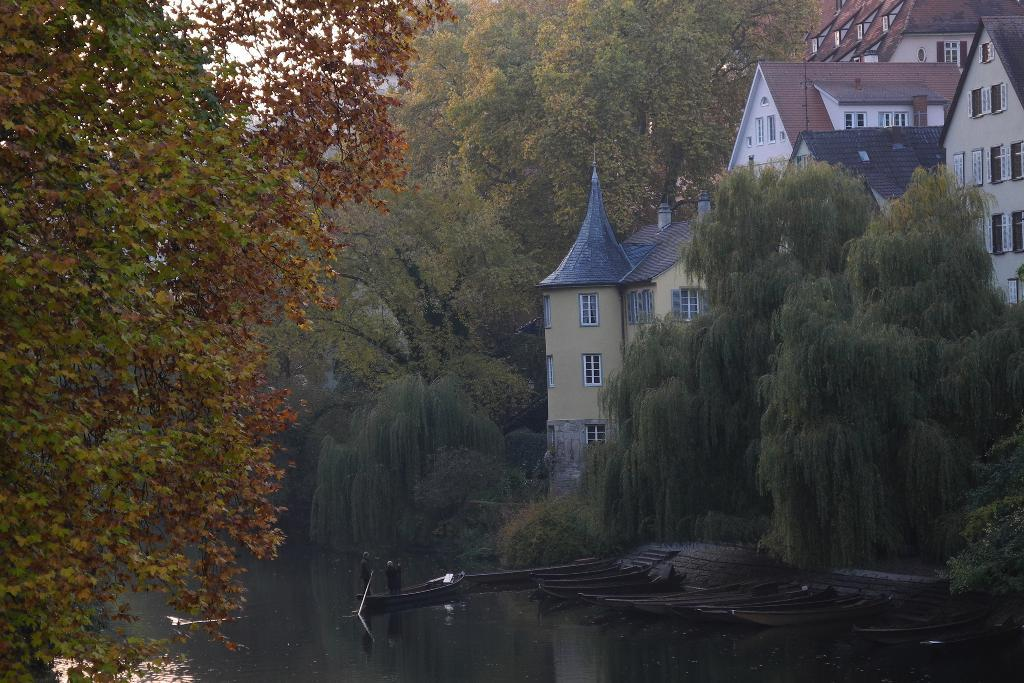What type of structures can be seen in the image? There are buildings in the image. What natural elements are present in the image? There are trees in the image. What mode of transportation can be seen on the water in the image? There are boats on the surface of the water in the image. Are there any living beings visible in the image? Yes, people are visible in the image. What reason is given for turning the page in the image? There is no page or reason mentioned in the image; it features buildings, trees, boats, and people. What type of picture is being drawn by the people in the image? There is no indication of anyone drawing a picture in the image. 